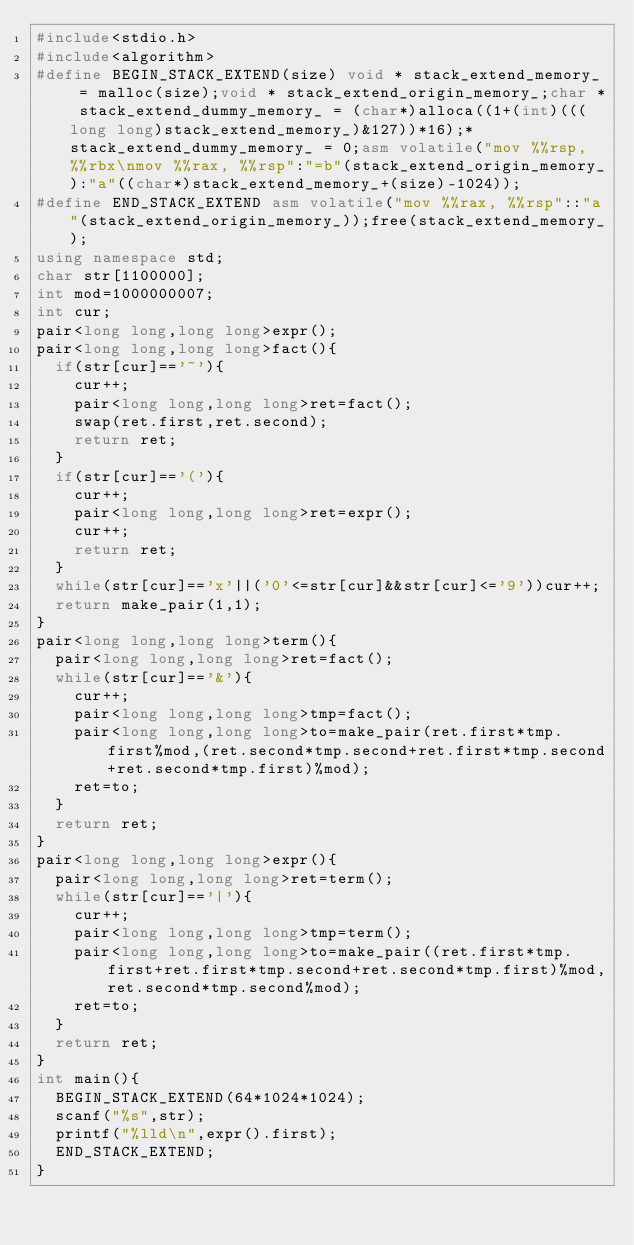<code> <loc_0><loc_0><loc_500><loc_500><_C++_>#include<stdio.h>
#include<algorithm>
#define BEGIN_STACK_EXTEND(size) void * stack_extend_memory_ = malloc(size);void * stack_extend_origin_memory_;char * stack_extend_dummy_memory_ = (char*)alloca((1+(int)(((long long)stack_extend_memory_)&127))*16);*stack_extend_dummy_memory_ = 0;asm volatile("mov %%rsp, %%rbx\nmov %%rax, %%rsp":"=b"(stack_extend_origin_memory_):"a"((char*)stack_extend_memory_+(size)-1024));
#define END_STACK_EXTEND asm volatile("mov %%rax, %%rsp"::"a"(stack_extend_origin_memory_));free(stack_extend_memory_);
using namespace std;
char str[1100000];
int mod=1000000007;
int cur;
pair<long long,long long>expr();
pair<long long,long long>fact(){
	if(str[cur]=='~'){
		cur++;
		pair<long long,long long>ret=fact();
		swap(ret.first,ret.second);
		return ret;
	}
	if(str[cur]=='('){
		cur++;
		pair<long long,long long>ret=expr();
		cur++;
		return ret;
	}
	while(str[cur]=='x'||('0'<=str[cur]&&str[cur]<='9'))cur++;
	return make_pair(1,1);
}
pair<long long,long long>term(){
	pair<long long,long long>ret=fact();
	while(str[cur]=='&'){
		cur++;
		pair<long long,long long>tmp=fact();
		pair<long long,long long>to=make_pair(ret.first*tmp.first%mod,(ret.second*tmp.second+ret.first*tmp.second+ret.second*tmp.first)%mod);
		ret=to;
	}
	return ret;
}
pair<long long,long long>expr(){
	pair<long long,long long>ret=term();
	while(str[cur]=='|'){
		cur++;
		pair<long long,long long>tmp=term();
		pair<long long,long long>to=make_pair((ret.first*tmp.first+ret.first*tmp.second+ret.second*tmp.first)%mod,ret.second*tmp.second%mod);
		ret=to;
	}
	return ret;
}
int main(){
	BEGIN_STACK_EXTEND(64*1024*1024);
	scanf("%s",str);
	printf("%lld\n",expr().first);
	END_STACK_EXTEND;
}</code> 